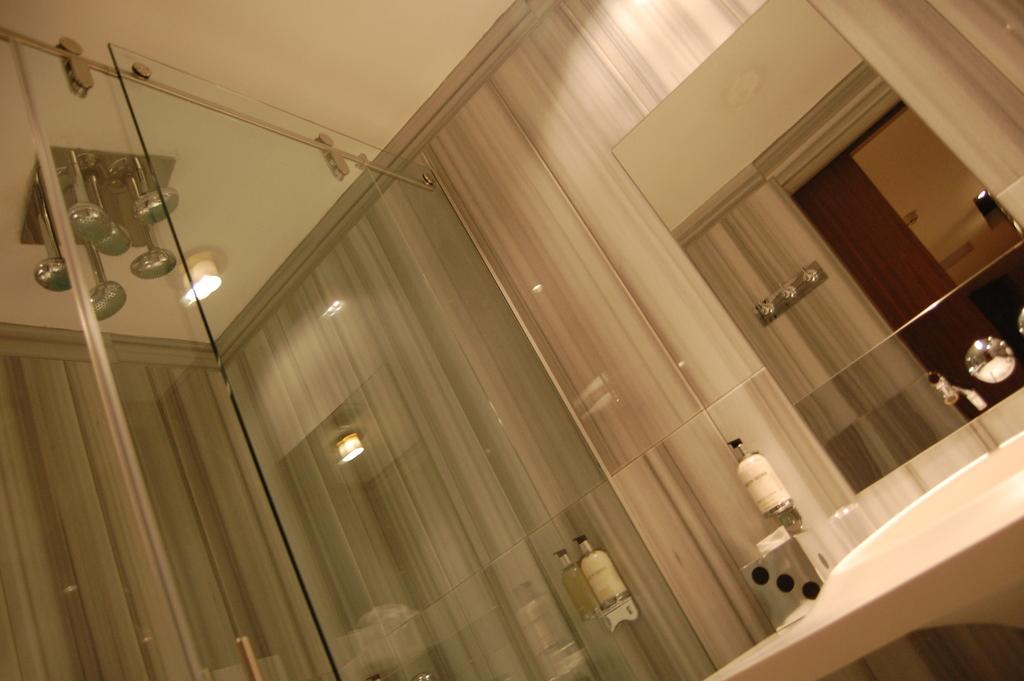What objects can be seen in the image that are typically used for holding liquids? There are bottles in the image. What can be found in the image that is used for washing or cleaning? There is a sink in the image. What is used to control the flow of water in the sink? There is a tap in the image. What is present in the image that provides illumination? There are lights in the image. What object is present in the image that can be used for drinking? There is a glass in the image. What is the result of the bottles' reflection on the glass? The reflection of the bottles is visible on the glass. Can you see any sea creatures swimming around the bottles in the image? There are no sea creatures present in the image; it is an indoor setting with bottles, a sink, a tap, lights, and a glass. Are there any worms crawling on the glass in the image? There are no worms visible on the glass in the image. 